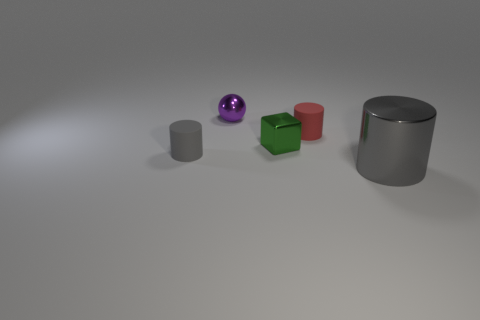Is there anything else that is the same shape as the green shiny thing?
Give a very brief answer. No. Does the red cylinder have the same size as the gray cylinder that is to the right of the block?
Your answer should be compact. No. There is a metal object that is behind the small gray thing and to the right of the tiny purple thing; what is its color?
Make the answer very short. Green. Is the number of tiny shiny objects right of the tiny purple sphere greater than the number of big gray shiny cylinders that are behind the red rubber thing?
Give a very brief answer. Yes. What is the size of the sphere that is made of the same material as the big cylinder?
Make the answer very short. Small. There is a gray object to the left of the purple metal object; what number of tiny green blocks are in front of it?
Offer a very short reply. 0. Is there another red matte object of the same shape as the large object?
Provide a succinct answer. Yes. What is the color of the cylinder that is in front of the tiny rubber cylinder in front of the green shiny cube?
Your response must be concise. Gray. Are there more shiny cubes than big cyan spheres?
Offer a very short reply. Yes. How many gray shiny cylinders are the same size as the shiny ball?
Your answer should be very brief. 0. 